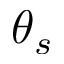<formula> <loc_0><loc_0><loc_500><loc_500>\theta _ { s }</formula> 